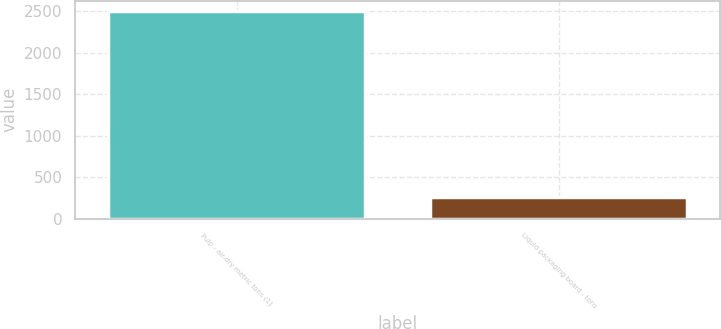<chart> <loc_0><loc_0><loc_500><loc_500><bar_chart><fcel>Pulp - air-dry metric tons (1)<fcel>Liquid packaging board - tons<nl><fcel>2502<fcel>258<nl></chart> 